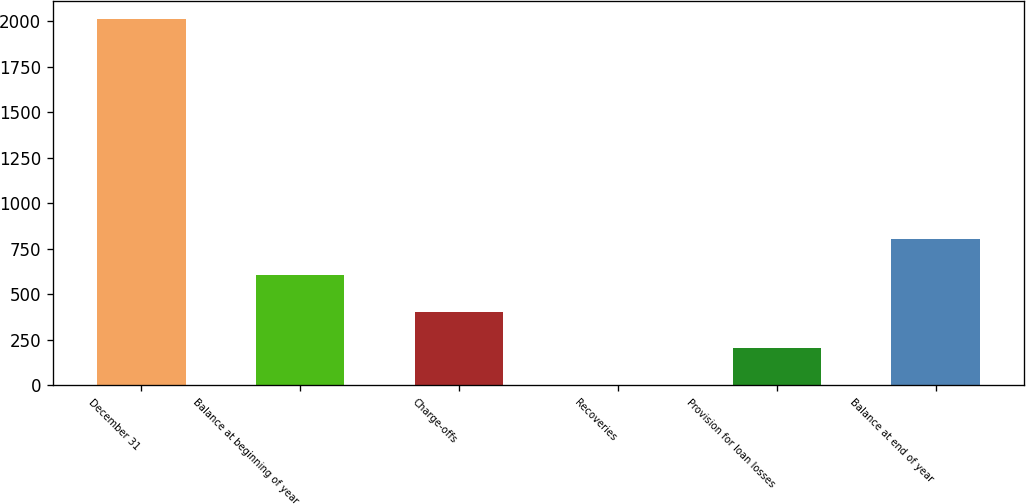Convert chart to OTSL. <chart><loc_0><loc_0><loc_500><loc_500><bar_chart><fcel>December 31<fcel>Balance at beginning of year<fcel>Charge-offs<fcel>Recoveries<fcel>Provision for loan losses<fcel>Balance at end of year<nl><fcel>2011<fcel>604.7<fcel>403.8<fcel>2<fcel>202.9<fcel>805.6<nl></chart> 